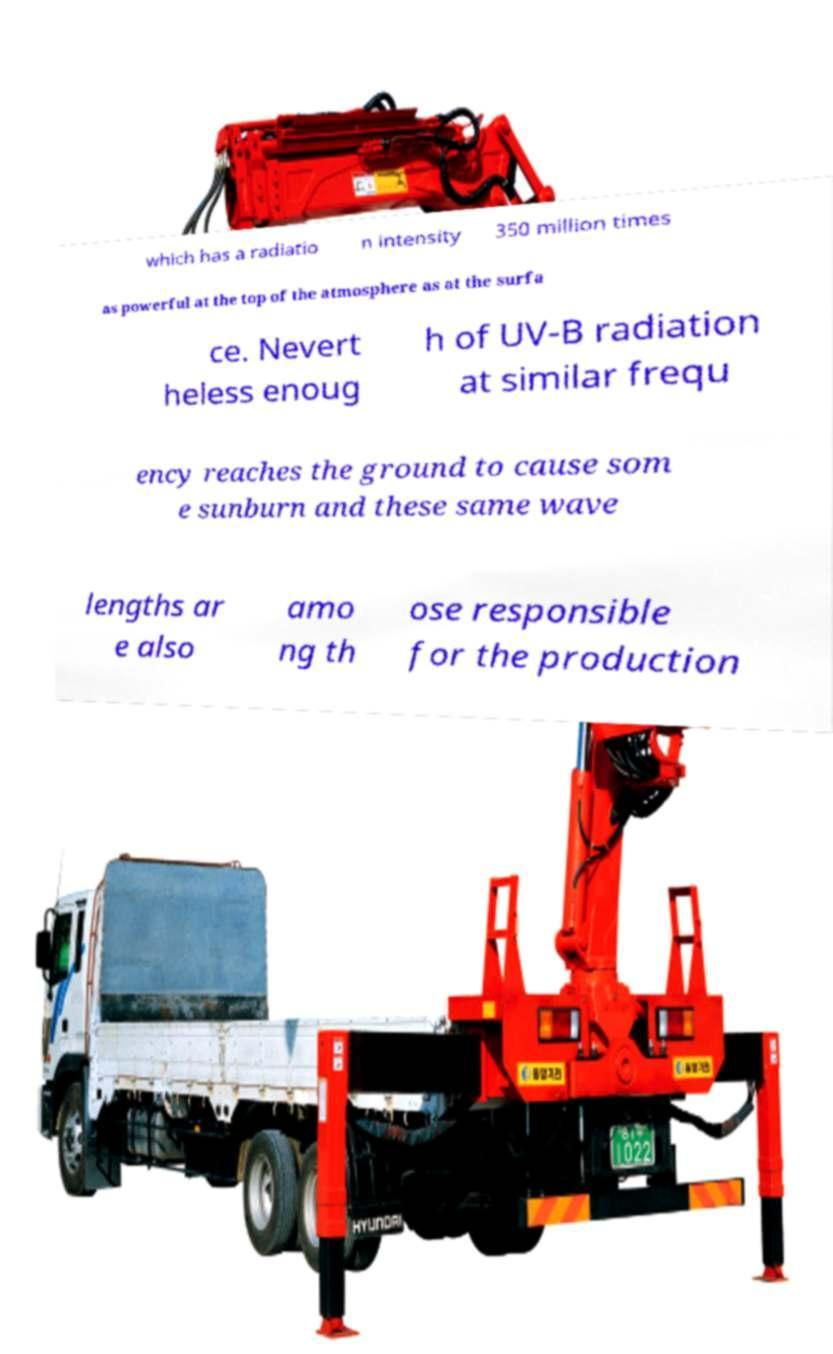Can you accurately transcribe the text from the provided image for me? which has a radiatio n intensity 350 million times as powerful at the top of the atmosphere as at the surfa ce. Nevert heless enoug h of UV-B radiation at similar frequ ency reaches the ground to cause som e sunburn and these same wave lengths ar e also amo ng th ose responsible for the production 